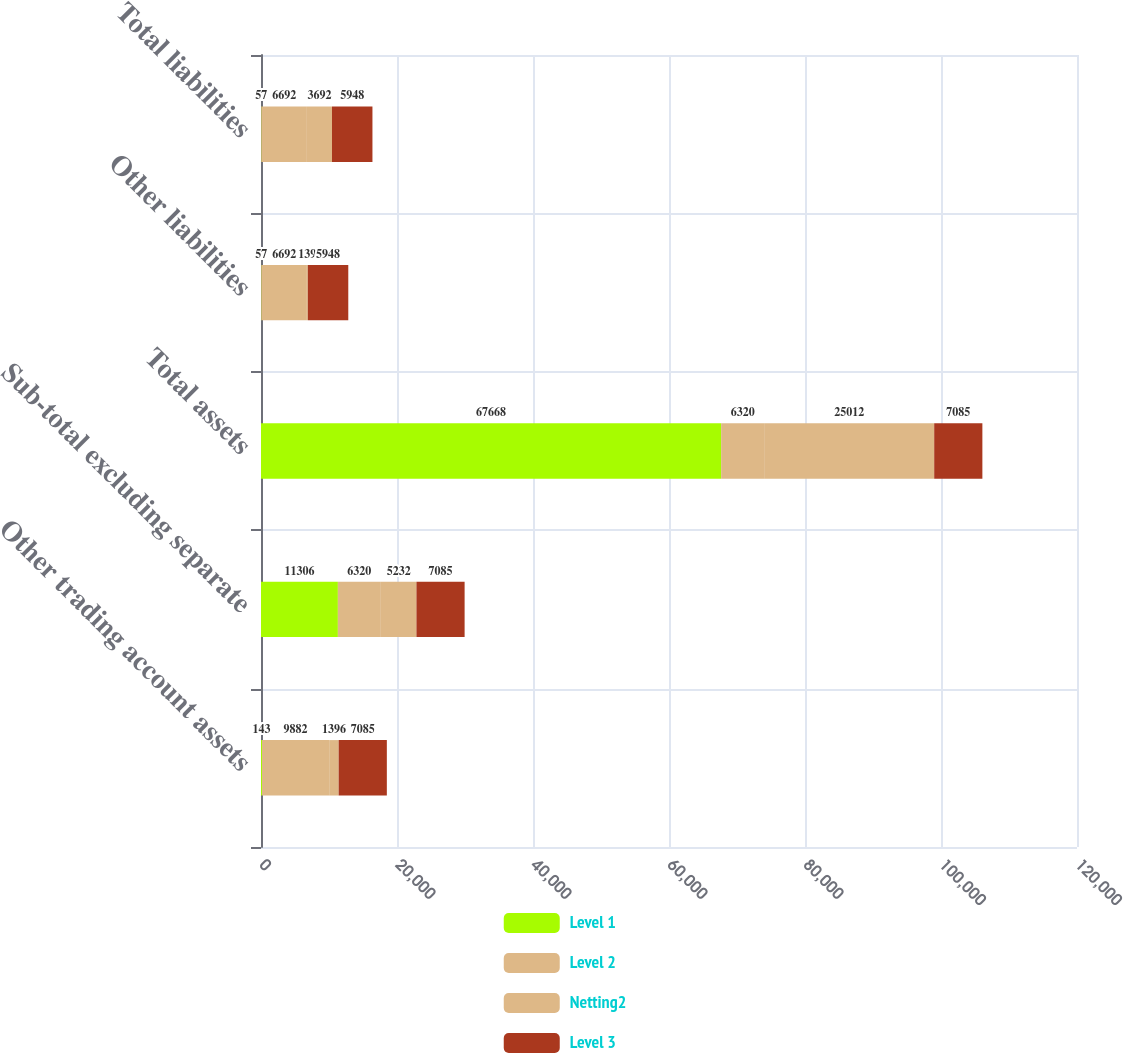Convert chart to OTSL. <chart><loc_0><loc_0><loc_500><loc_500><stacked_bar_chart><ecel><fcel>Other trading account assets<fcel>Sub-total excluding separate<fcel>Total assets<fcel>Other liabilities<fcel>Total liabilities<nl><fcel>Level 1<fcel>143<fcel>11306<fcel>67668<fcel>57<fcel>57<nl><fcel>Level 2<fcel>9882<fcel>6320<fcel>6320<fcel>6692<fcel>6692<nl><fcel>Netting2<fcel>1396<fcel>5232<fcel>25012<fcel>139<fcel>3692<nl><fcel>Level 3<fcel>7085<fcel>7085<fcel>7085<fcel>5948<fcel>5948<nl></chart> 